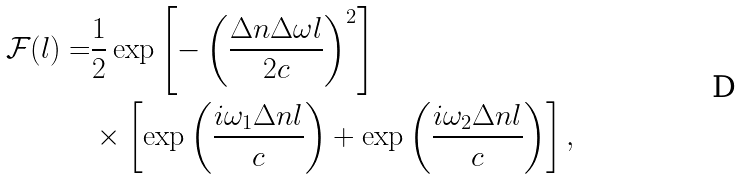<formula> <loc_0><loc_0><loc_500><loc_500>\mathcal { F } ( l ) = & \frac { 1 } { 2 } \exp \left [ - \left ( \frac { \Delta n \Delta \omega l } { 2 c } \right ) ^ { 2 } \right ] \\ & \times \left [ \exp \left ( \frac { i \omega _ { 1 } \Delta n l } { c } \right ) + \exp \left ( \frac { i \omega _ { 2 } \Delta n l } { c } \right ) \right ] ,</formula> 